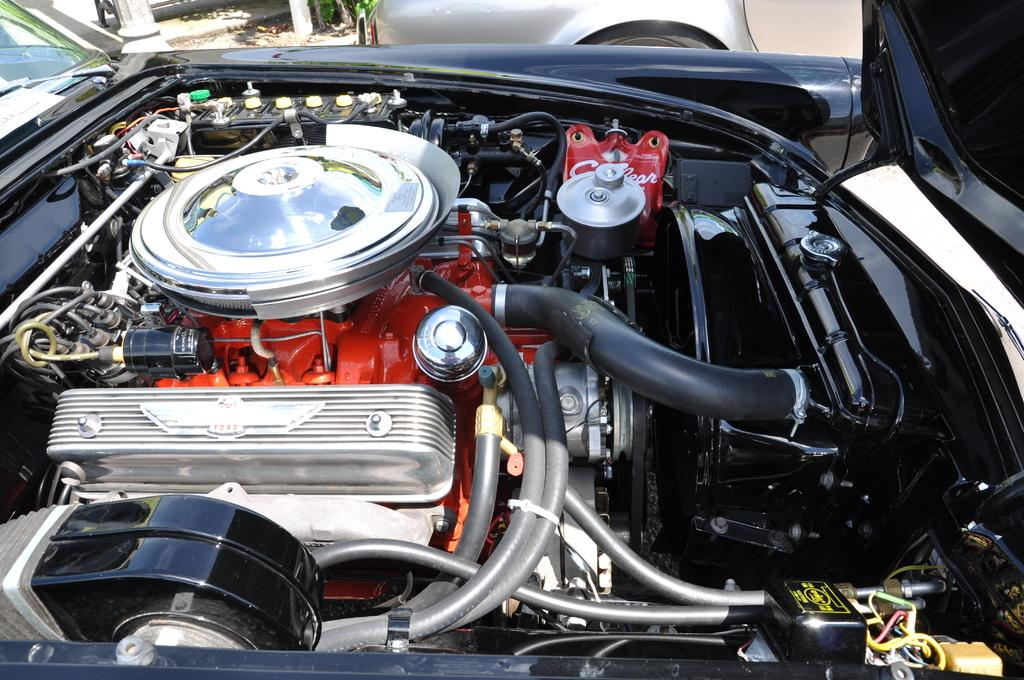What is the main subject of the image? The main subject of the image is an engine. What type of engine is it? The engine belongs to a motor vehicle. How much does the ray weigh in the image? There is no ray present in the image, so its weight cannot be determined. 